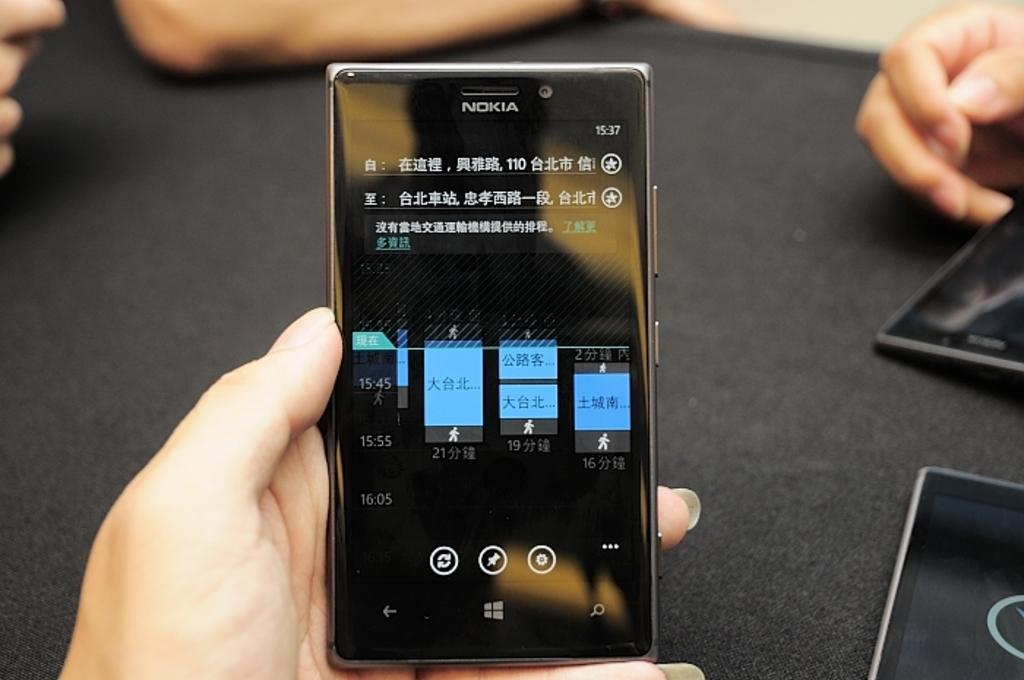Provide a one-sentence caption for the provided image. A hand is holding a phone with graphs indicating the gains and losses of a Chinese company. 